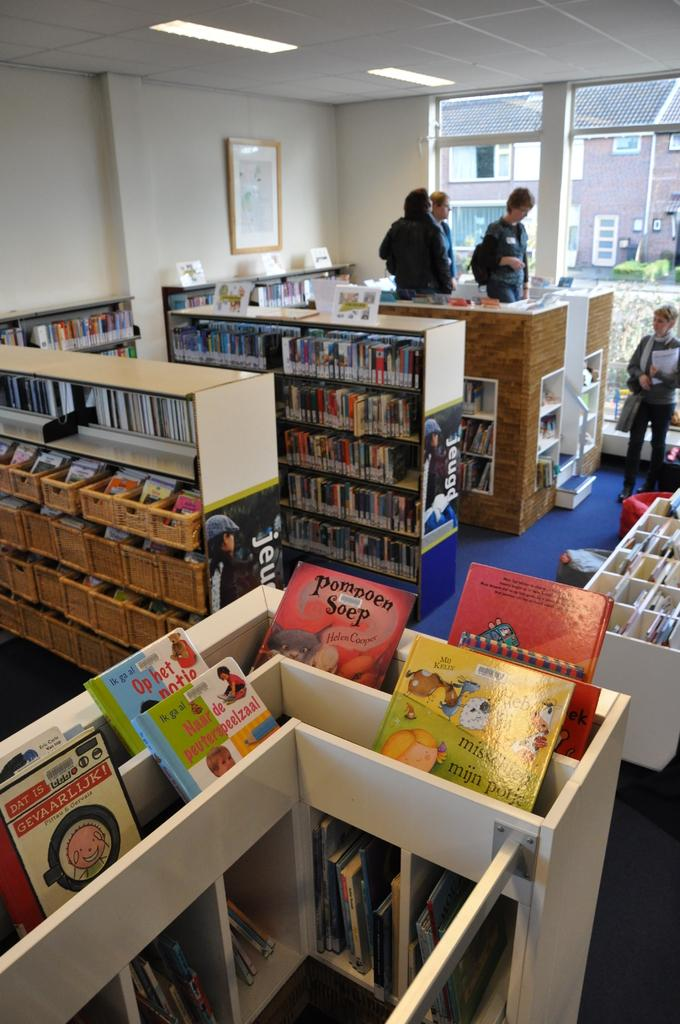<image>
Share a concise interpretation of the image provided. A children's book called Pompoen Soep sits on a shelf with other children's books 